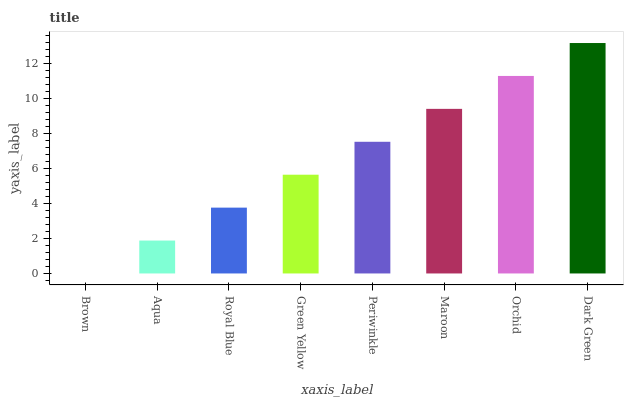Is Brown the minimum?
Answer yes or no. Yes. Is Dark Green the maximum?
Answer yes or no. Yes. Is Aqua the minimum?
Answer yes or no. No. Is Aqua the maximum?
Answer yes or no. No. Is Aqua greater than Brown?
Answer yes or no. Yes. Is Brown less than Aqua?
Answer yes or no. Yes. Is Brown greater than Aqua?
Answer yes or no. No. Is Aqua less than Brown?
Answer yes or no. No. Is Periwinkle the high median?
Answer yes or no. Yes. Is Green Yellow the low median?
Answer yes or no. Yes. Is Maroon the high median?
Answer yes or no. No. Is Dark Green the low median?
Answer yes or no. No. 